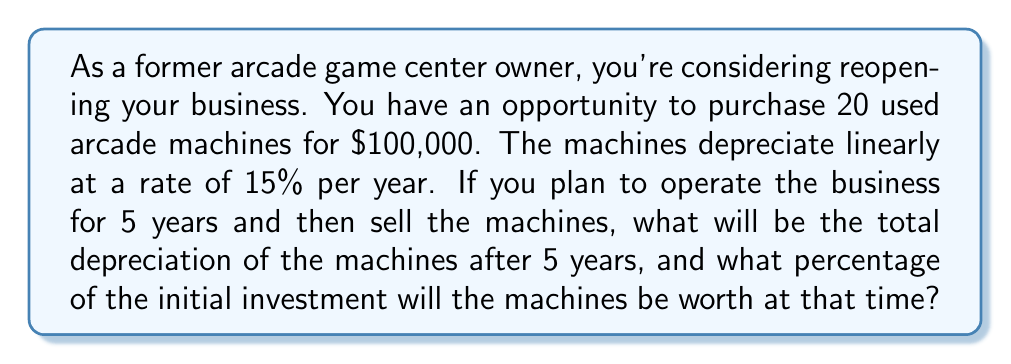Help me with this question. Let's approach this problem step by step:

1) First, we need to calculate the annual depreciation:
   Annual depreciation rate = 15%
   Initial value = $100,000
   Annual depreciation = $100,000 * 15% = $15,000

2) To find the total depreciation after 5 years, we multiply the annual depreciation by 5:
   Total depreciation = $15,000 * 5 = $75,000

3) Now, let's calculate the remaining value after 5 years:
   Remaining value = Initial value - Total depreciation
   Remaining value = $100,000 - $75,000 = $25,000

4) To express the remaining value as a percentage of the initial investment:
   Percentage = (Remaining value / Initial value) * 100
   Percentage = ($25,000 / $100,000) * 100 = 25%

We can express this mathematically using a linear equation:

$$V(t) = V_0 - rt$$

Where:
$V(t)$ is the value at time $t$
$V_0$ is the initial value
$r$ is the annual depreciation rate in dollars
$t$ is the time in years

For our problem:
$$V(5) = 100,000 - 15,000 * 5 = 25,000$$

This confirms our calculation.
Answer: The total depreciation after 5 years will be $75,000, and the machines will be worth 25% of their initial value. 